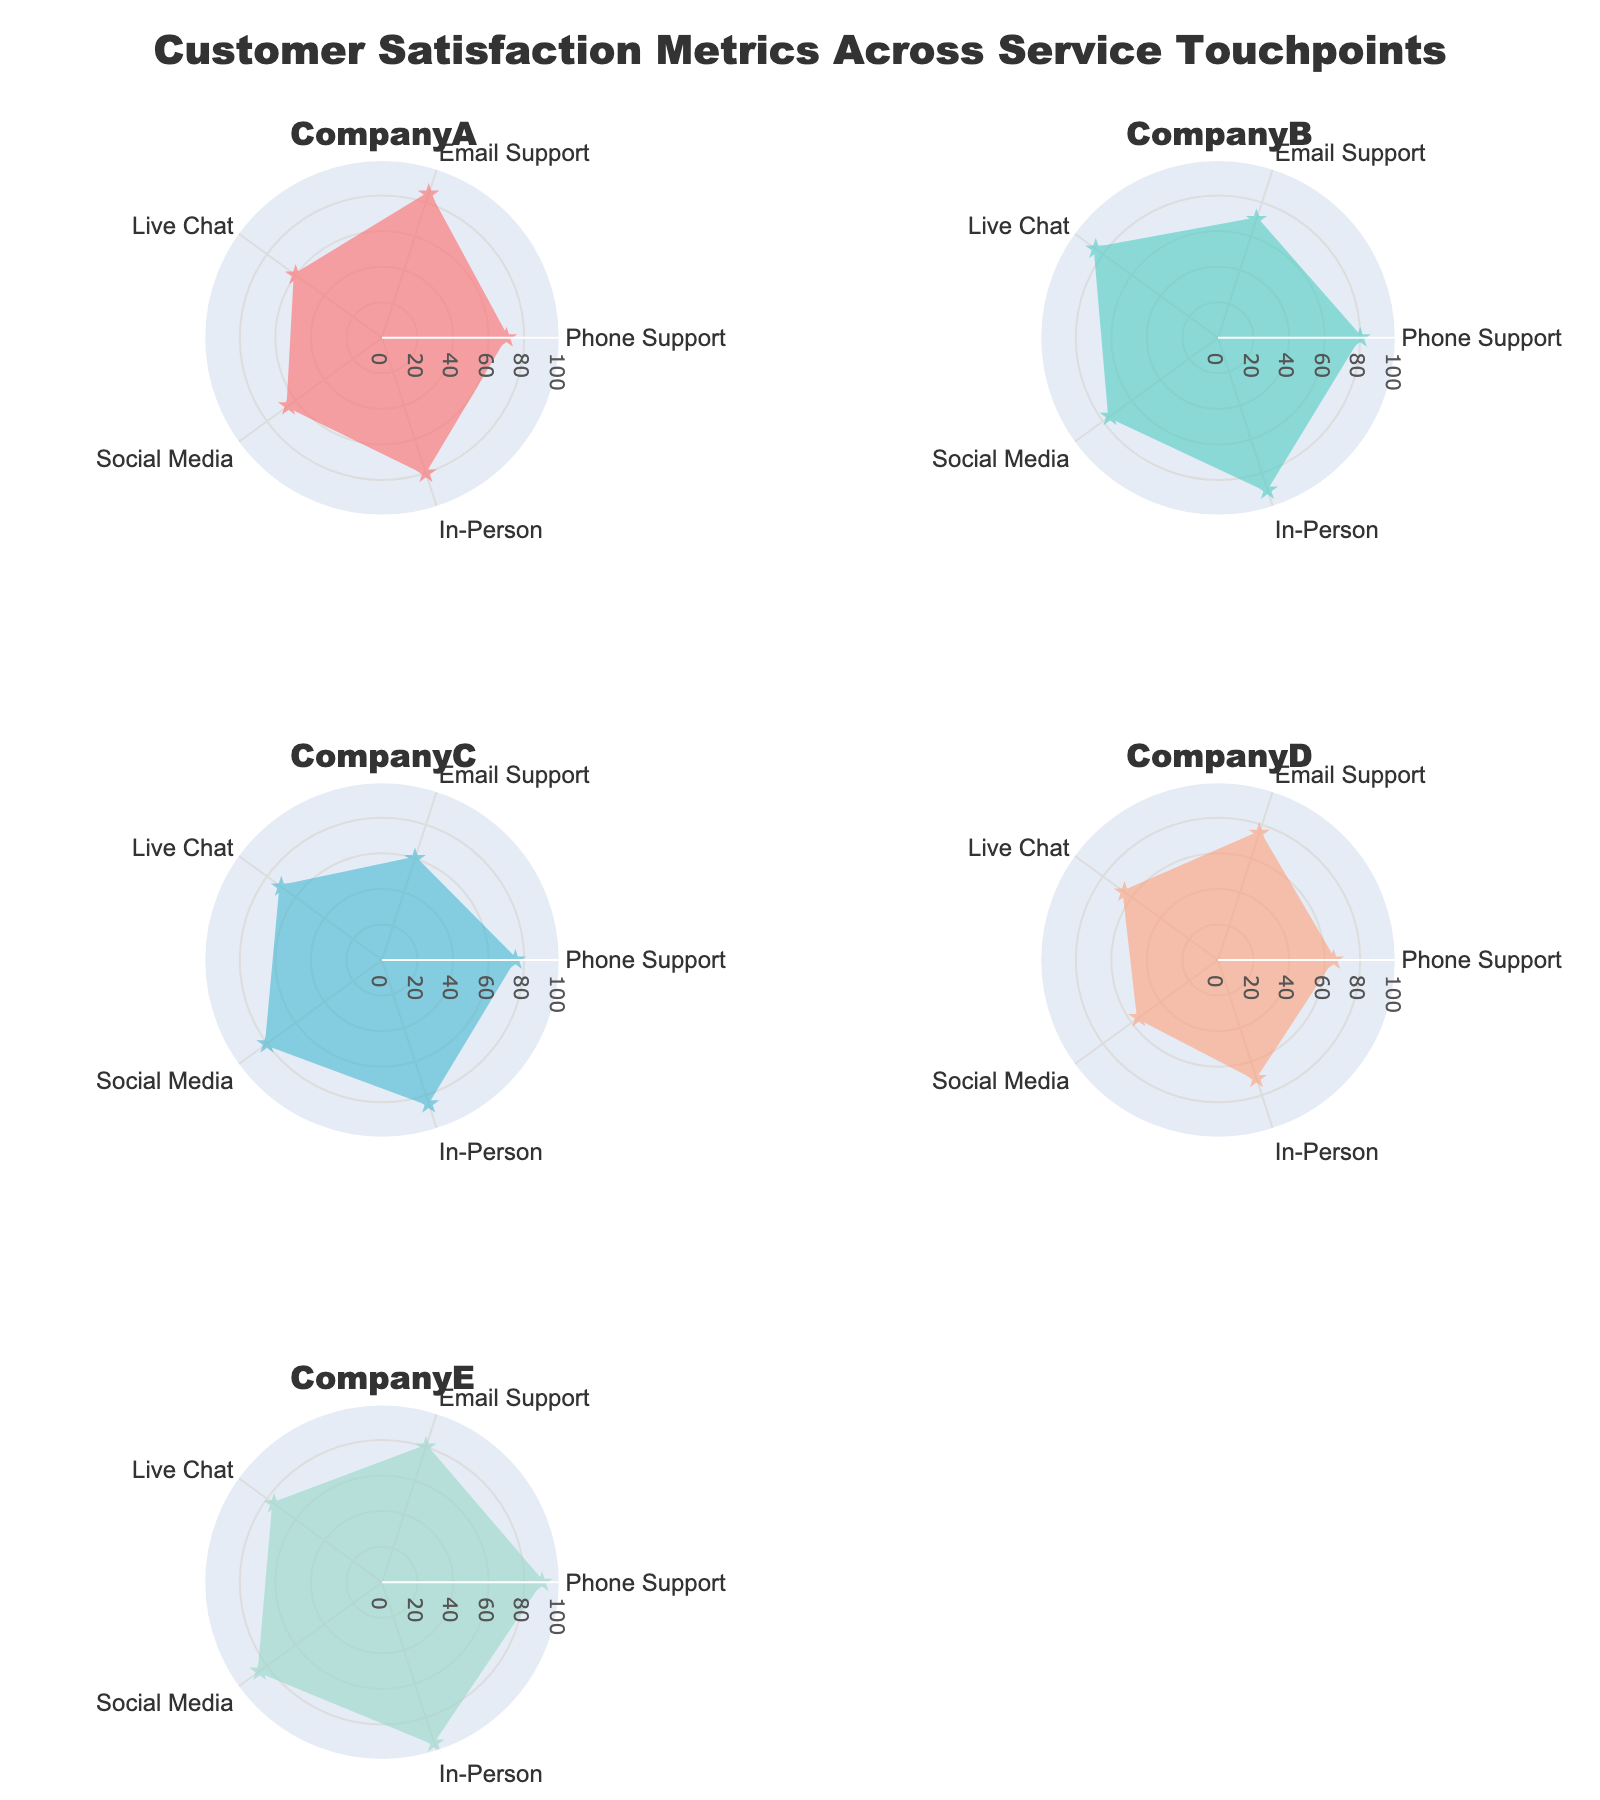What is the title of the figure? Look at the top part of the figure where the title is centered.
Answer: Customer Satisfaction Metrics Across Service Touchpoints How many service touchpoints are evaluated for each company? Count the categories represented in each subplot's radar chart. There are Phone Support, Email Support, Live Chat, Social Media, and In-Person.
Answer: 5 Which company has the highest satisfaction in In-Person support? Locate the 'In-Person' values plotted for each company and identify the highest one. CompanyE has an In-Person satisfaction rating of 95.
Answer: CompanyE What is the average satisfaction score for CompanyA across all touchpoints? Add up the satisfaction scores for CompanyA and divide by the number of touchpoints: (70 + 85 + 60 + 65 + 80) / 5 = 72.
Answer: 72 Which company shows the most consistent satisfaction ratings across all touchpoints? Check the uniformity of the plots for each company. CompanyA has values ranging from 60 to 85, which are relatively consistent.
Answer: CompanyA How does CompanyB's Social Media support compare to its Phone Support? Compare the values of Social Media and Phone Support for CompanyB. CompanyB has a Social Media rating of 75 and a Phone Support rating of 80.
Answer: Lower Which company has the lowest satisfaction rating in Email Support? Identify the lowest value in the Email Support category among all companies. CompanyC has a rating of 60 in Email Support.
Answer: CompanyC What are the top two companies in Live Chat satisfaction? Identify the top two values for Live Chat support and their respective companies. CompanyB (85) and CompanyE (75) have the highest values.
Answer: CompanyB and CompanyE By how much does CompanyE's In-Person support satisfaction exceed CompanyD's? Compute the difference between CompanyE's and CompanyD's In-Person satisfaction ratings: 95 - 70 = 25.
Answer: 25 Which company has the greatest variance in its satisfaction ratings across all service touchpoints? Calculate the variance for each company by examining the spread of their ratings. CompanyD ranges from 55 to 75, showing the greatest variance.
Answer: CompanyD 